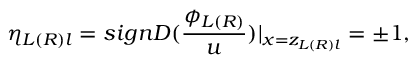<formula> <loc_0><loc_0><loc_500><loc_500>\eta _ { L ( R ) l } = s i g n D ( \frac { \phi _ { L ( R ) } } u ) | _ { x = z _ { L ( R ) l } } = \pm 1 ,</formula> 